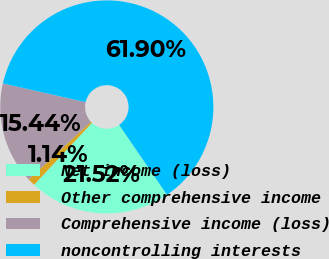Convert chart to OTSL. <chart><loc_0><loc_0><loc_500><loc_500><pie_chart><fcel>Net income (loss)<fcel>Other comprehensive income<fcel>Comprehensive income (loss)<fcel>noncontrolling interests<nl><fcel>21.52%<fcel>1.14%<fcel>15.44%<fcel>61.91%<nl></chart> 